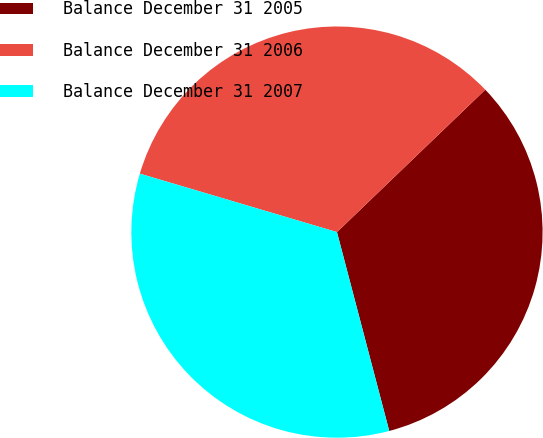Convert chart to OTSL. <chart><loc_0><loc_0><loc_500><loc_500><pie_chart><fcel>Balance December 31 2005<fcel>Balance December 31 2006<fcel>Balance December 31 2007<nl><fcel>33.09%<fcel>33.24%<fcel>33.68%<nl></chart> 